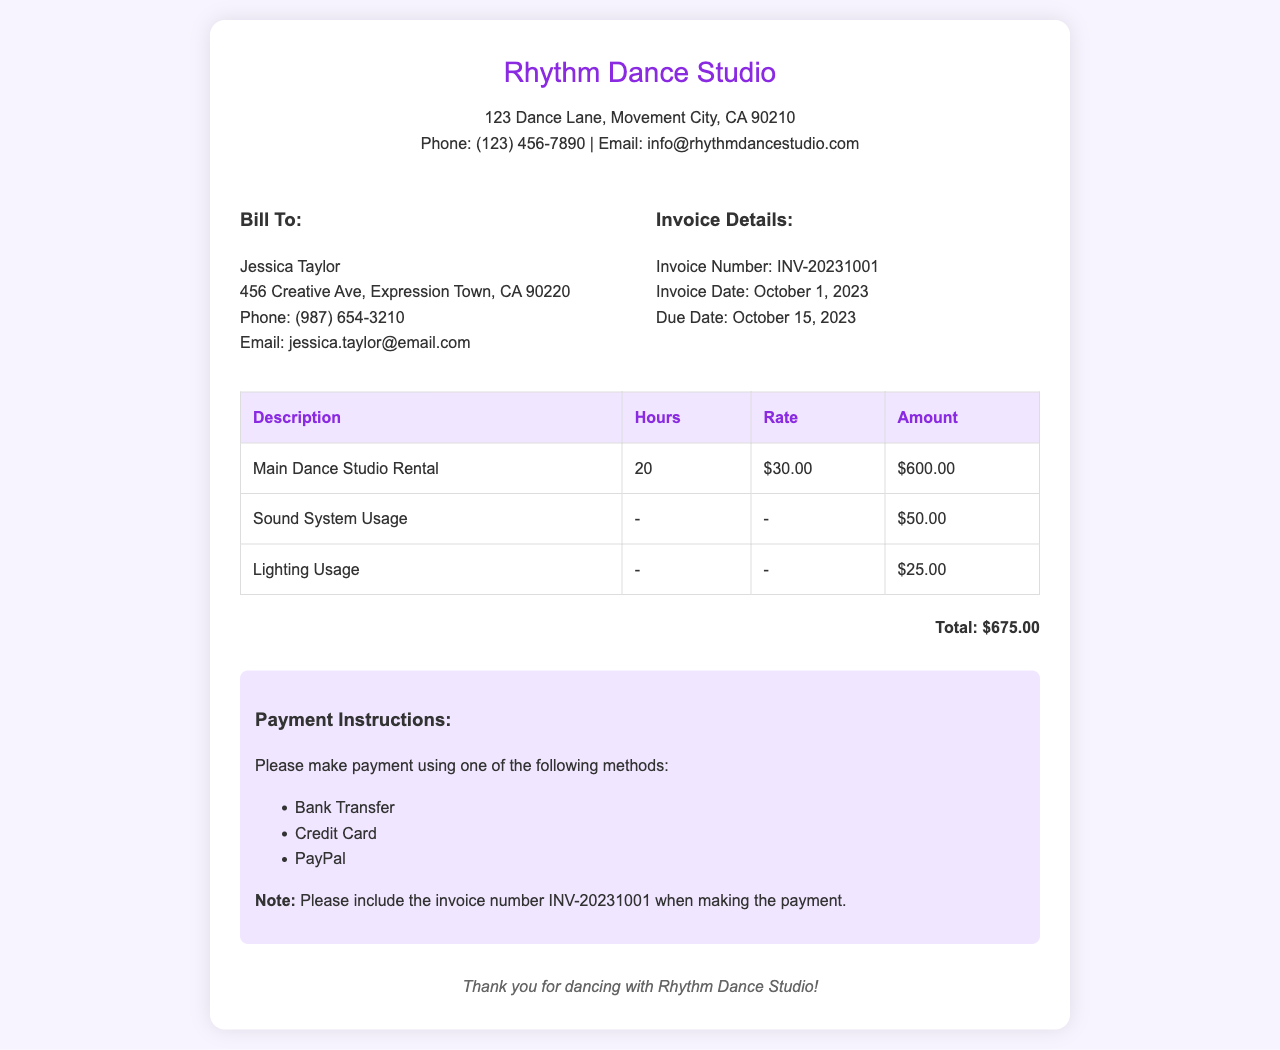What is the studio name? The studio name is prominently featured at the top of the invoice.
Answer: Rhythm Dance Studio Who is the invoice billed to? The billing information is listed under the "Bill To" section.
Answer: Jessica Taylor What is the invoice number? The invoice number is provided in the "Invoice Details" section.
Answer: INV-20231001 How many hours of main dance studio rental were used? The hours used for the main dance studio rental are stated in the table.
Answer: 20 What is the total amount due? The total amount is calculated and displayed at the bottom of the invoice.
Answer: $675.00 What is the due date for the payment? The due date is listed under the "Invoice Details" section.
Answer: October 15, 2023 What additional amenity has a charge of $50.00? The amenity charges are listed in the table with their corresponding prices.
Answer: Sound System Usage How much is the charge for Lighting Usage? The pricing for the lighting is indicated in the table.
Answer: $25.00 What payment methods are accepted? Payment methods are detailed in the "Payment Instructions" section.
Answer: Bank Transfer, Credit Card, PayPal 